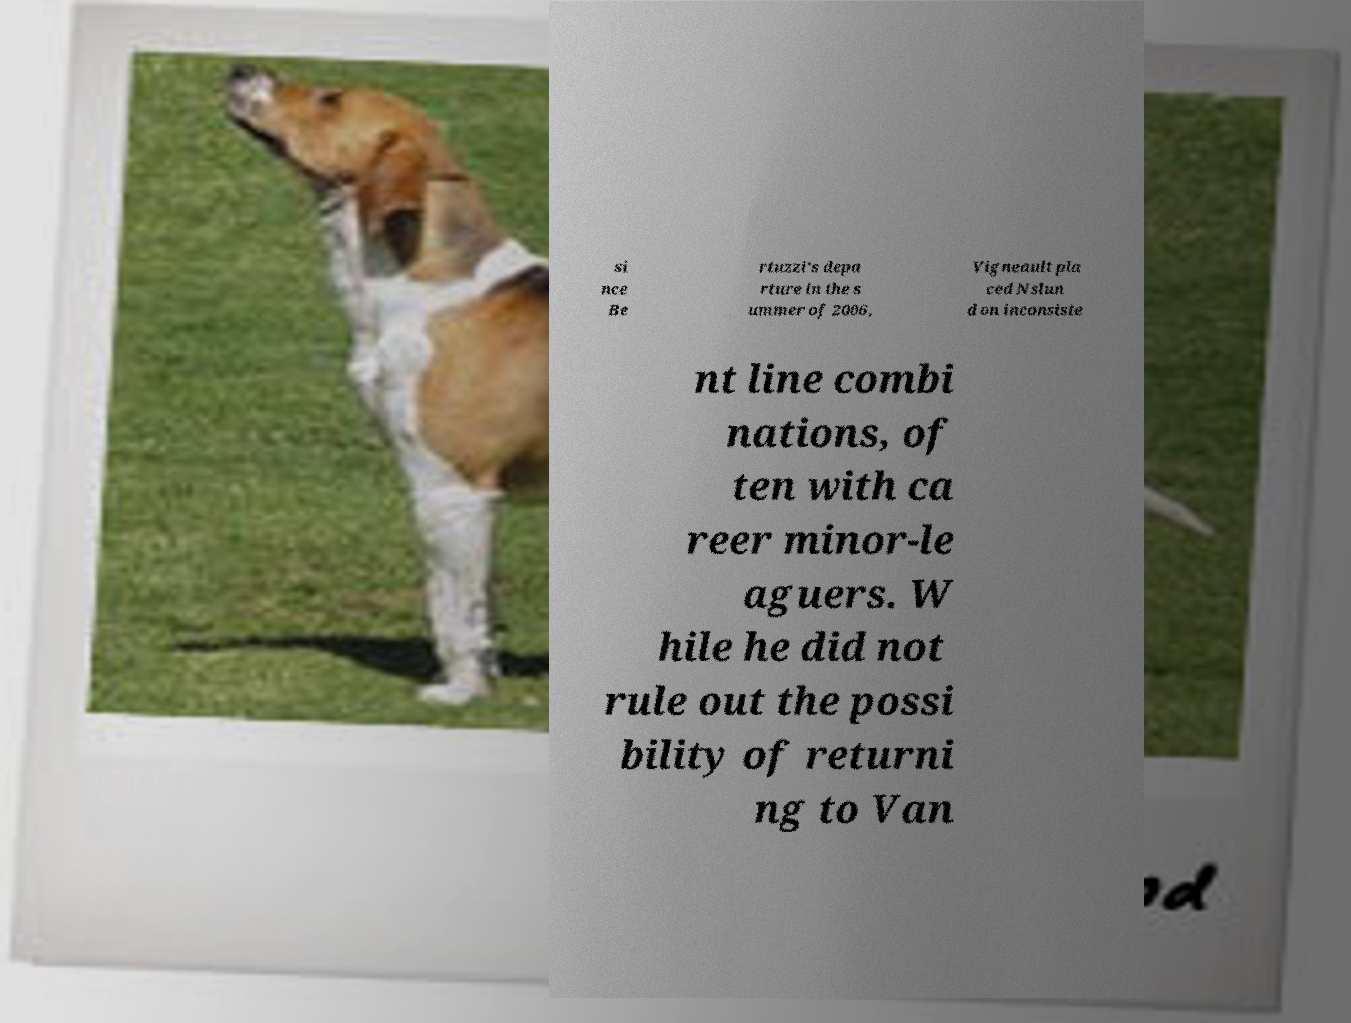Could you extract and type out the text from this image? si nce Be rtuzzi's depa rture in the s ummer of 2006, Vigneault pla ced Nslun d on inconsiste nt line combi nations, of ten with ca reer minor-le aguers. W hile he did not rule out the possi bility of returni ng to Van 